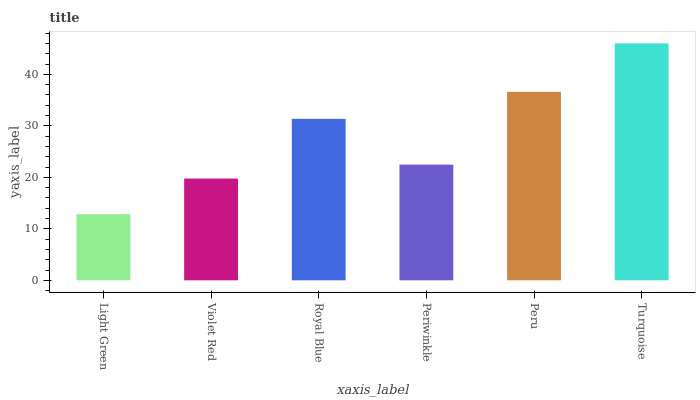Is Light Green the minimum?
Answer yes or no. Yes. Is Turquoise the maximum?
Answer yes or no. Yes. Is Violet Red the minimum?
Answer yes or no. No. Is Violet Red the maximum?
Answer yes or no. No. Is Violet Red greater than Light Green?
Answer yes or no. Yes. Is Light Green less than Violet Red?
Answer yes or no. Yes. Is Light Green greater than Violet Red?
Answer yes or no. No. Is Violet Red less than Light Green?
Answer yes or no. No. Is Royal Blue the high median?
Answer yes or no. Yes. Is Periwinkle the low median?
Answer yes or no. Yes. Is Light Green the high median?
Answer yes or no. No. Is Violet Red the low median?
Answer yes or no. No. 